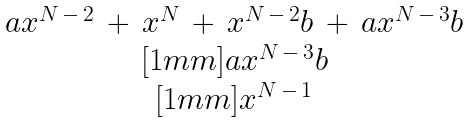Convert formula to latex. <formula><loc_0><loc_0><loc_500><loc_500>\begin{matrix} a x ^ { N \, - \, 2 } \, + \, x ^ { N } \, + \, x ^ { N \, - \, 2 } b \, + \, a x ^ { N \, - \, 3 } b \\ [ 1 m m ] a x ^ { N \, - \, 3 } b \\ [ 1 m m ] x ^ { N \, - \, 1 } \end{matrix}</formula> 